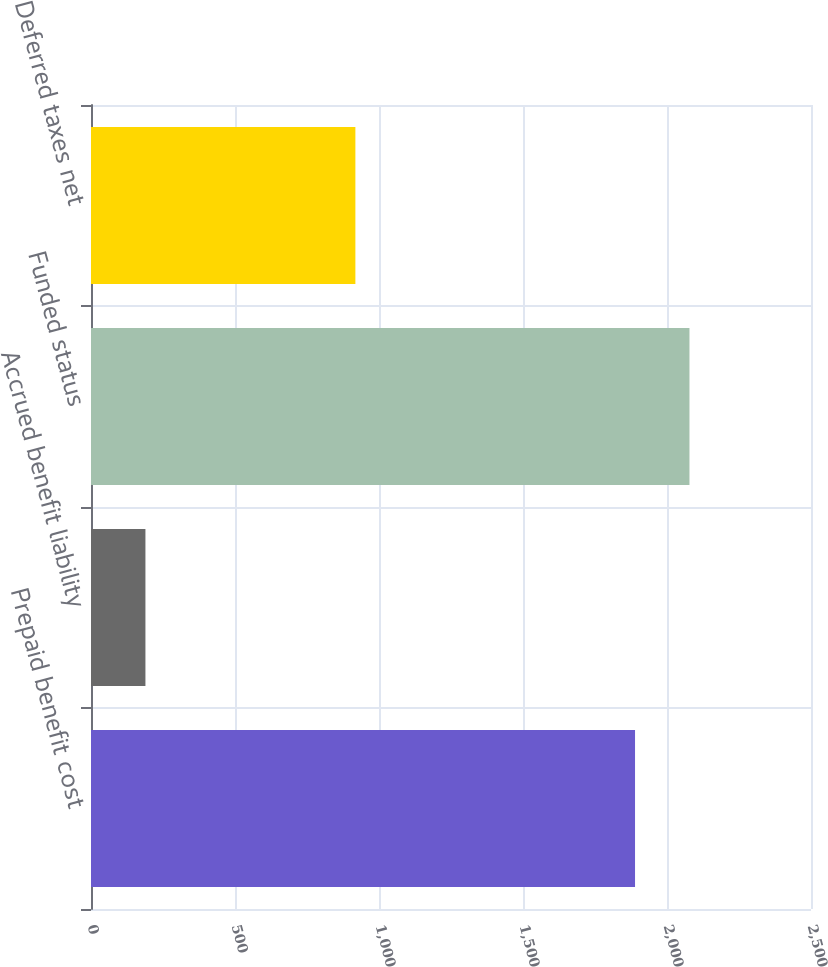Convert chart. <chart><loc_0><loc_0><loc_500><loc_500><bar_chart><fcel>Prepaid benefit cost<fcel>Accrued benefit liability<fcel>Funded status<fcel>Deferred taxes net<nl><fcel>1889<fcel>189<fcel>2078<fcel>918<nl></chart> 